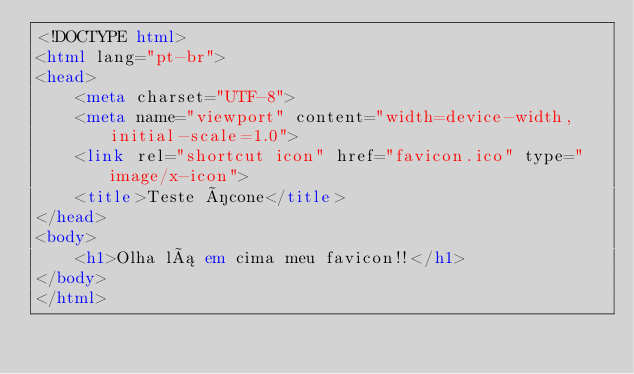Convert code to text. <code><loc_0><loc_0><loc_500><loc_500><_HTML_><!DOCTYPE html>
<html lang="pt-br">
<head>
    <meta charset="UTF-8">
    <meta name="viewport" content="width=device-width, initial-scale=1.0">
    <link rel="shortcut icon" href="favicon.ico" type="image/x-icon">
    <title>Teste ícone</title>
</head>
<body>
    <h1>Olha lá em cima meu favicon!!</h1>
</body>
</html></code> 